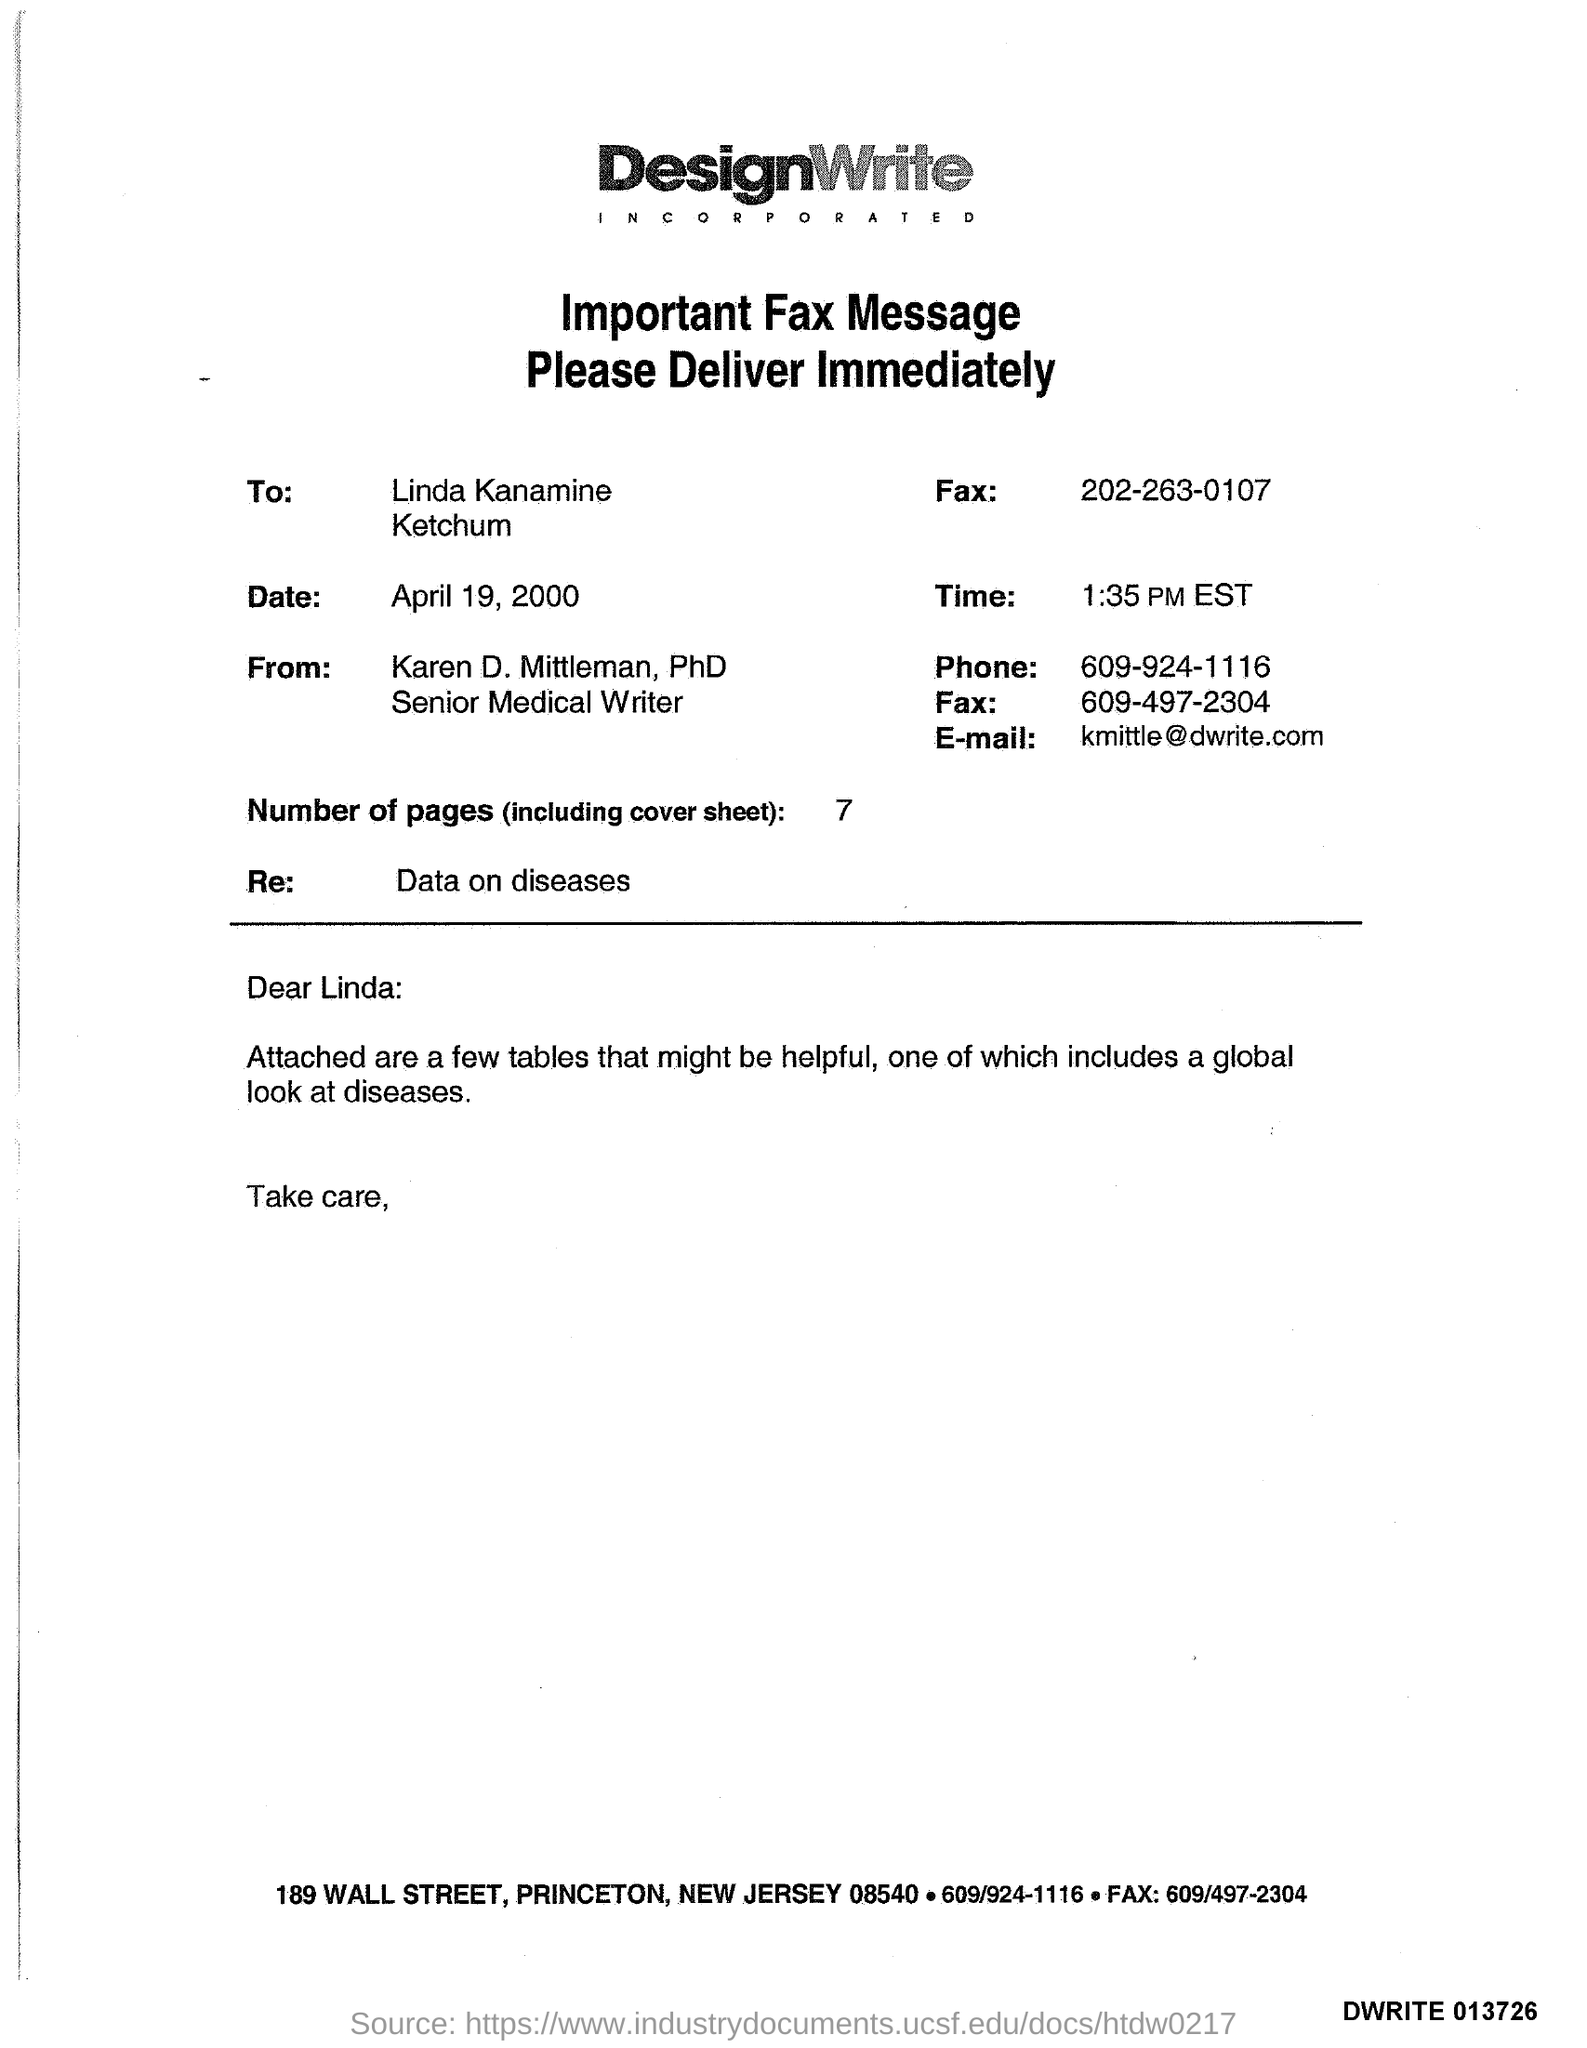Draw attention to some important aspects in this diagram. There are 7 pages in the sheet. The receiver fax number is 202-263-0107. The sender's fax number is 609-497-2304. The sender's phone number is 609-924-1116. The memorandum is addressed to Linda Kanamine. 